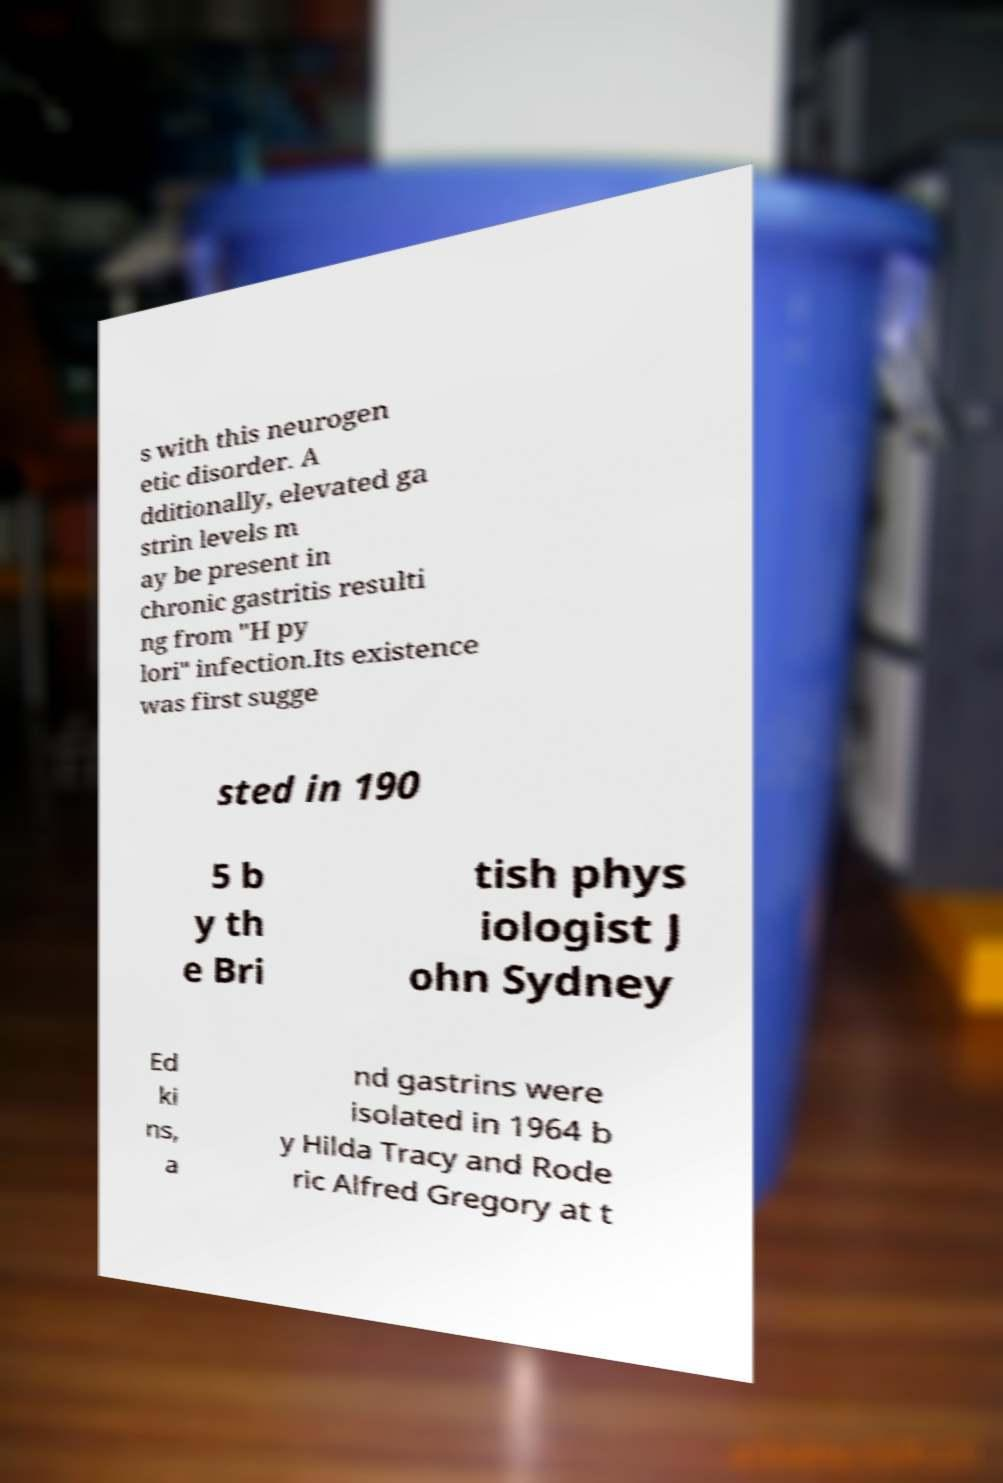Can you accurately transcribe the text from the provided image for me? s with this neurogen etic disorder. A dditionally, elevated ga strin levels m ay be present in chronic gastritis resulti ng from "H py lori" infection.Its existence was first sugge sted in 190 5 b y th e Bri tish phys iologist J ohn Sydney Ed ki ns, a nd gastrins were isolated in 1964 b y Hilda Tracy and Rode ric Alfred Gregory at t 